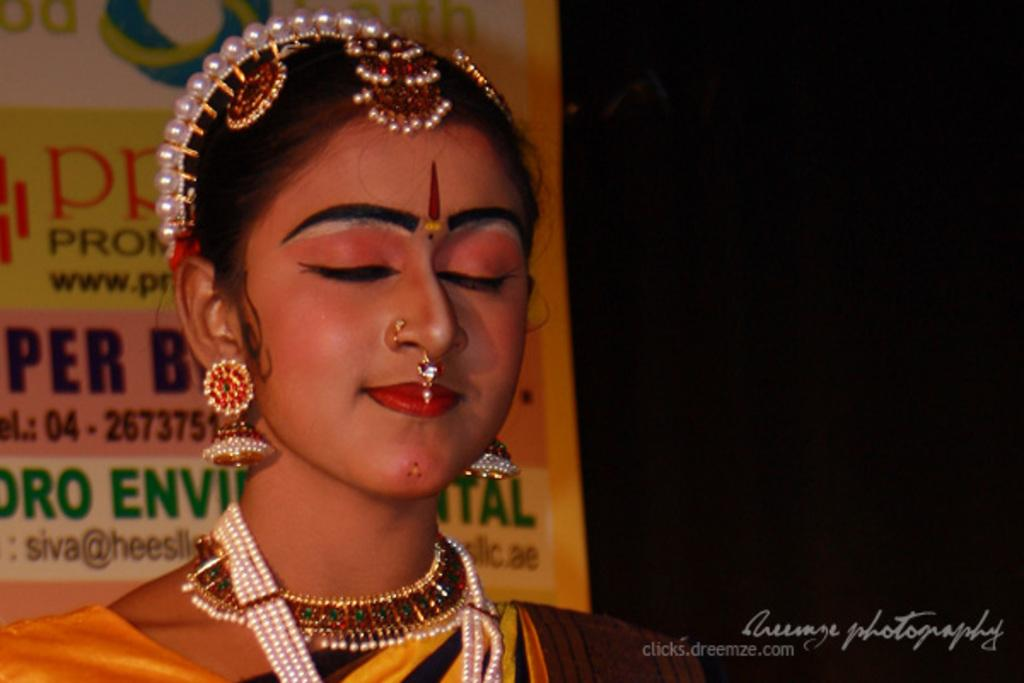Who is the main subject in the picture? There is a woman in the picture. What is the woman wearing in the image? The woman is wearing ornaments. What can be seen in the background of the picture? There is a banner in the background of the picture with some text. Where is the text located in the image? There is text visible at the bottom right corner of the picture. How much dust can be seen on the side of the woman in the image? There is no dust visible on the woman or in the image. 